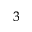Convert formula to latex. <formula><loc_0><loc_0><loc_500><loc_500>_ { 3 }</formula> 